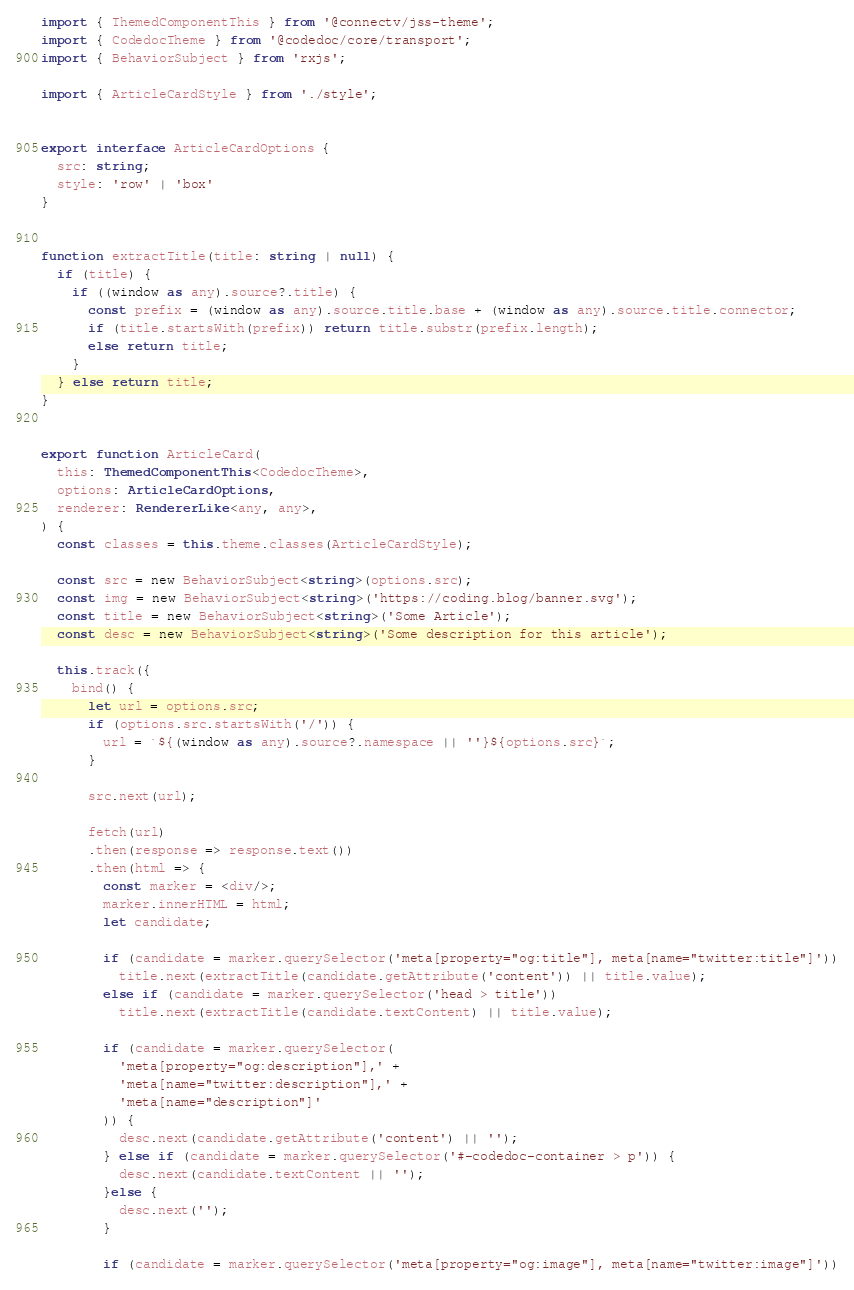Convert code to text. <code><loc_0><loc_0><loc_500><loc_500><_TypeScript_>import { ThemedComponentThis } from '@connectv/jss-theme';
import { CodedocTheme } from '@codedoc/core/transport';
import { BehaviorSubject } from 'rxjs';

import { ArticleCardStyle } from './style';


export interface ArticleCardOptions {
  src: string;
  style: 'row' | 'box'
}


function extractTitle(title: string | null) {
  if (title) {
    if ((window as any).source?.title) {
      const prefix = (window as any).source.title.base + (window as any).source.title.connector;
      if (title.startsWith(prefix)) return title.substr(prefix.length);
      else return title;
    }
  } else return title;
}


export function ArticleCard(
  this: ThemedComponentThis<CodedocTheme>,
  options: ArticleCardOptions,
  renderer: RendererLike<any, any>,
) {
  const classes = this.theme.classes(ArticleCardStyle);

  const src = new BehaviorSubject<string>(options.src);
  const img = new BehaviorSubject<string>('https://coding.blog/banner.svg');
  const title = new BehaviorSubject<string>('Some Article');
  const desc = new BehaviorSubject<string>('Some description for this article');

  this.track({
    bind() {
      let url = options.src;
      if (options.src.startsWith('/')) {
        url = `${(window as any).source?.namespace || ''}${options.src}`;
      }

      src.next(url);

      fetch(url)
      .then(response => response.text())
      .then(html => {
        const marker = <div/>;
        marker.innerHTML = html;
        let candidate;

        if (candidate = marker.querySelector('meta[property="og:title"], meta[name="twitter:title"]'))
          title.next(extractTitle(candidate.getAttribute('content')) || title.value);
        else if (candidate = marker.querySelector('head > title'))
          title.next(extractTitle(candidate.textContent) || title.value);

        if (candidate = marker.querySelector(
          'meta[property="og:description"],' +
          'meta[name="twitter:description"],' +
          'meta[name="description"]'
        )) {
          desc.next(candidate.getAttribute('content') || '');
        } else if (candidate = marker.querySelector('#-codedoc-container > p')) {
          desc.next(candidate.textContent || '');
        }else {
          desc.next('');
        }

        if (candidate = marker.querySelector('meta[property="og:image"], meta[name="twitter:image"]'))</code> 